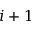Convert formula to latex. <formula><loc_0><loc_0><loc_500><loc_500>i + 1</formula> 